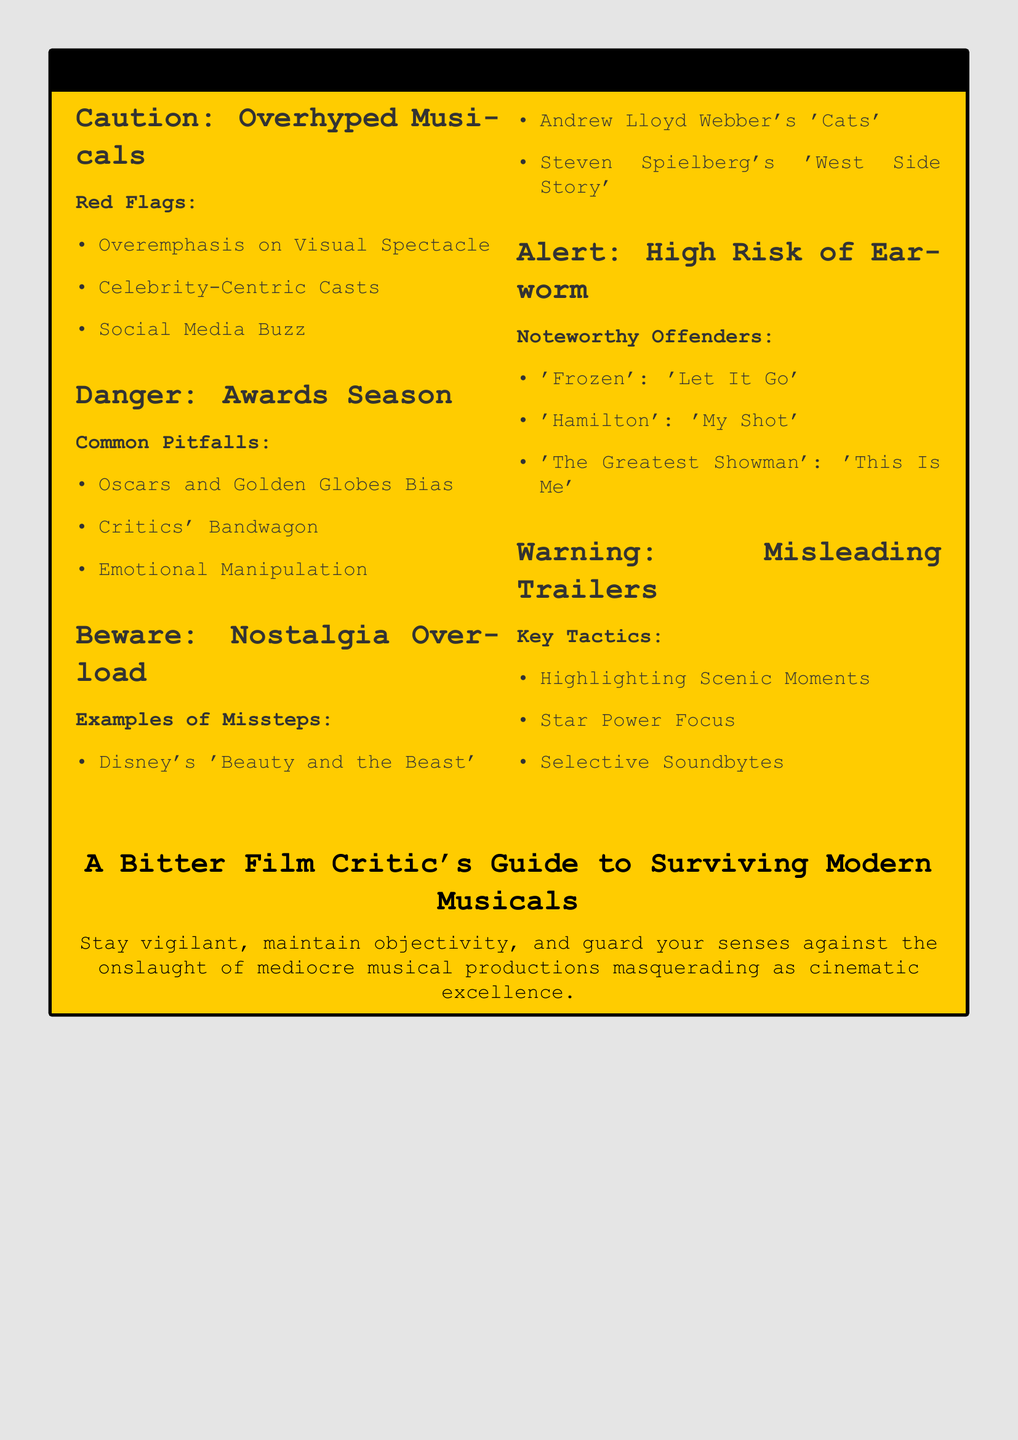What is the color of the warning box? The warning box is filled with a specific color that is defined in the document, which is a type of light yellow.
Answer: warningcolor What movie is listed as an example of nostalgia overload? One of the examples provided under nostalgia overload indicates a specific film that was remade and criticized.
Answer: Beauty and the Beast What is highlighted in the "Danger: Awards Season" section? The document lists various common pitfalls related to awards season, which impact the perception of musical films, identifying specific biases.
Answer: Oscars and Golden Globes Bias What song from "Frozen" is mentioned as a high-risk earworm? The particular song from "Frozen" is identified in the document as one that may stick in one's head annoyingly, making it a "high-risk" example.
Answer: Let It Go What tactic is discussed under the "Warning: Misleading Trailers" section? The document specifies different strategies that may be employed to create a deceptive impression of a musical film, choosing one specific tactic for explanation.
Answer: Highlighting Scenic Moments What is the primary focus of the document? The warning label serves a specific purpose, primarily aimed at guiding individuals through the pitfalls of contemporary musicals, a broader idea or theme.
Answer: Guide to Surviving Modern Musicals 